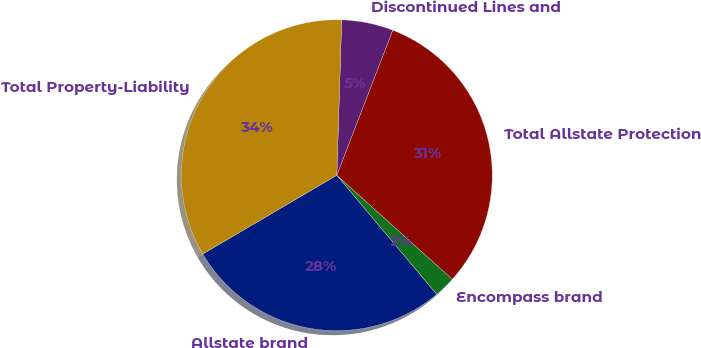<chart> <loc_0><loc_0><loc_500><loc_500><pie_chart><fcel>Allstate brand<fcel>Encompass brand<fcel>Total Allstate Protection<fcel>Discontinued Lines and<fcel>Total Property-Liability<nl><fcel>27.66%<fcel>2.22%<fcel>30.81%<fcel>5.36%<fcel>33.95%<nl></chart> 